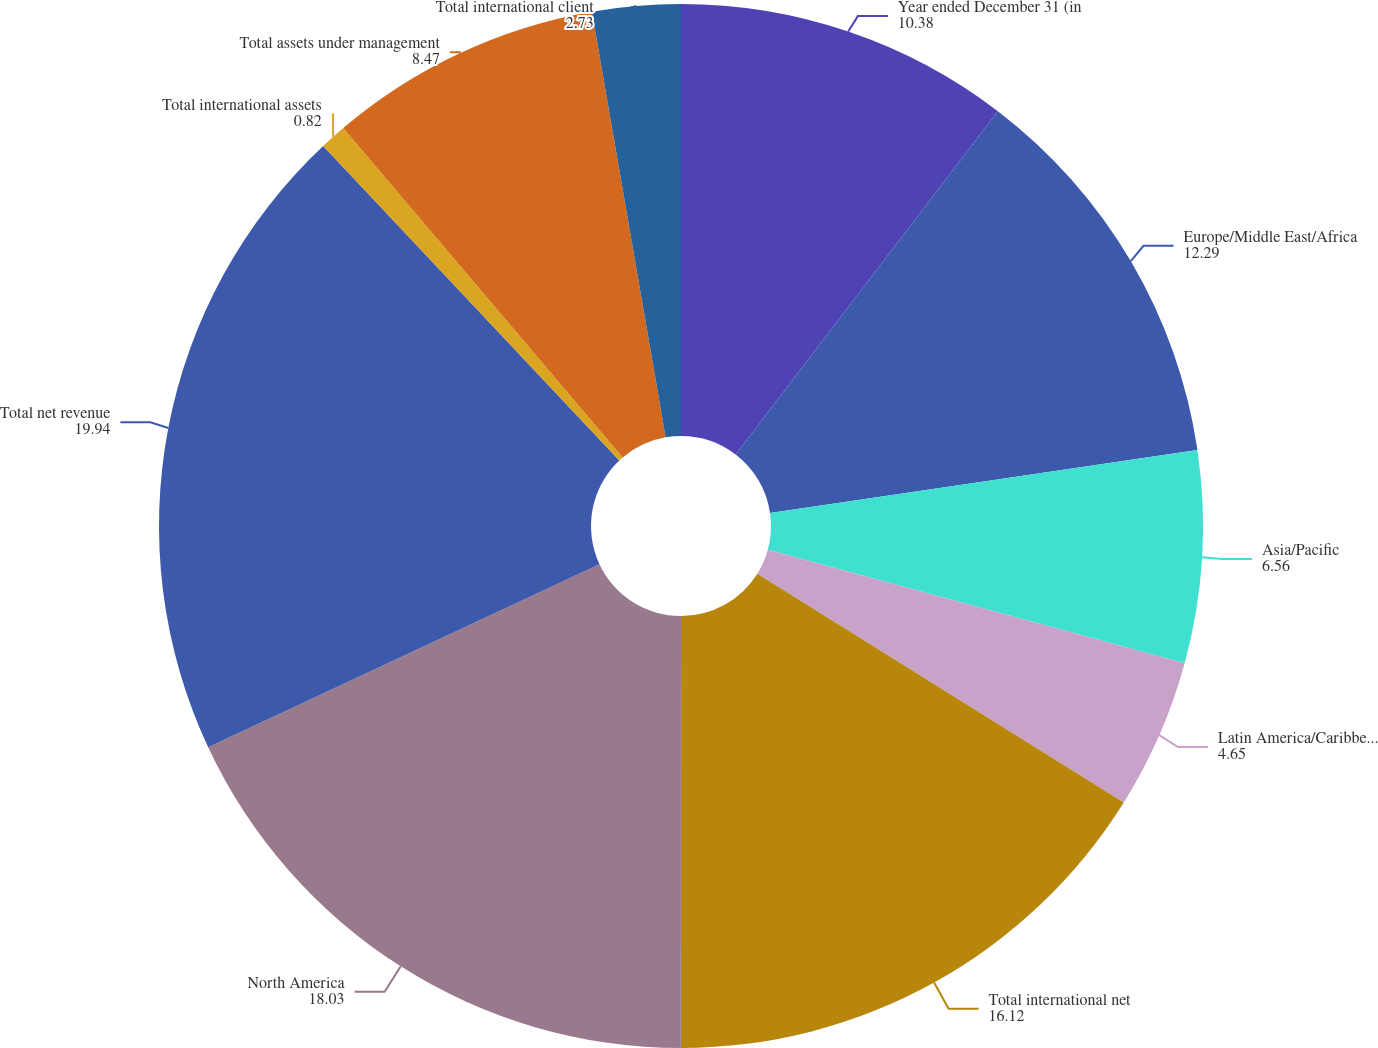Convert chart. <chart><loc_0><loc_0><loc_500><loc_500><pie_chart><fcel>Year ended December 31 (in<fcel>Europe/Middle East/Africa<fcel>Asia/Pacific<fcel>Latin America/Caribbean<fcel>Total international net<fcel>North America<fcel>Total net revenue<fcel>Total international assets<fcel>Total assets under management<fcel>Total international client<nl><fcel>10.38%<fcel>12.29%<fcel>6.56%<fcel>4.65%<fcel>16.12%<fcel>18.03%<fcel>19.94%<fcel>0.82%<fcel>8.47%<fcel>2.73%<nl></chart> 